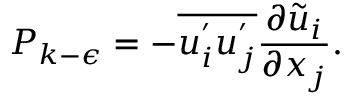<formula> <loc_0><loc_0><loc_500><loc_500>P _ { k - \epsilon } = - \overline { { u _ { i } ^ { ^ { \prime } } u _ { j } ^ { ^ { \prime } } } } \frac { \partial \widetilde { u } _ { i } } { \partial x _ { j } } .</formula> 